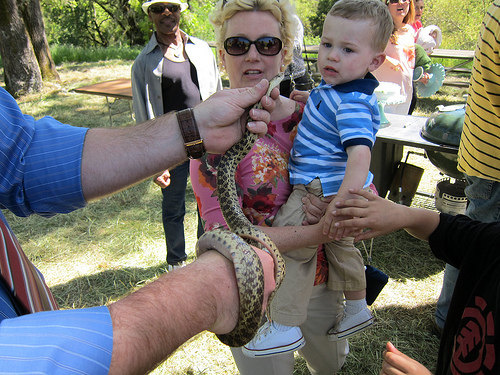<image>
Can you confirm if the snake is on the wrist? Yes. Looking at the image, I can see the snake is positioned on top of the wrist, with the wrist providing support. Is there a snake on the table? No. The snake is not positioned on the table. They may be near each other, but the snake is not supported by or resting on top of the table. Is the man in front of the shoe? Yes. The man is positioned in front of the shoe, appearing closer to the camera viewpoint. 